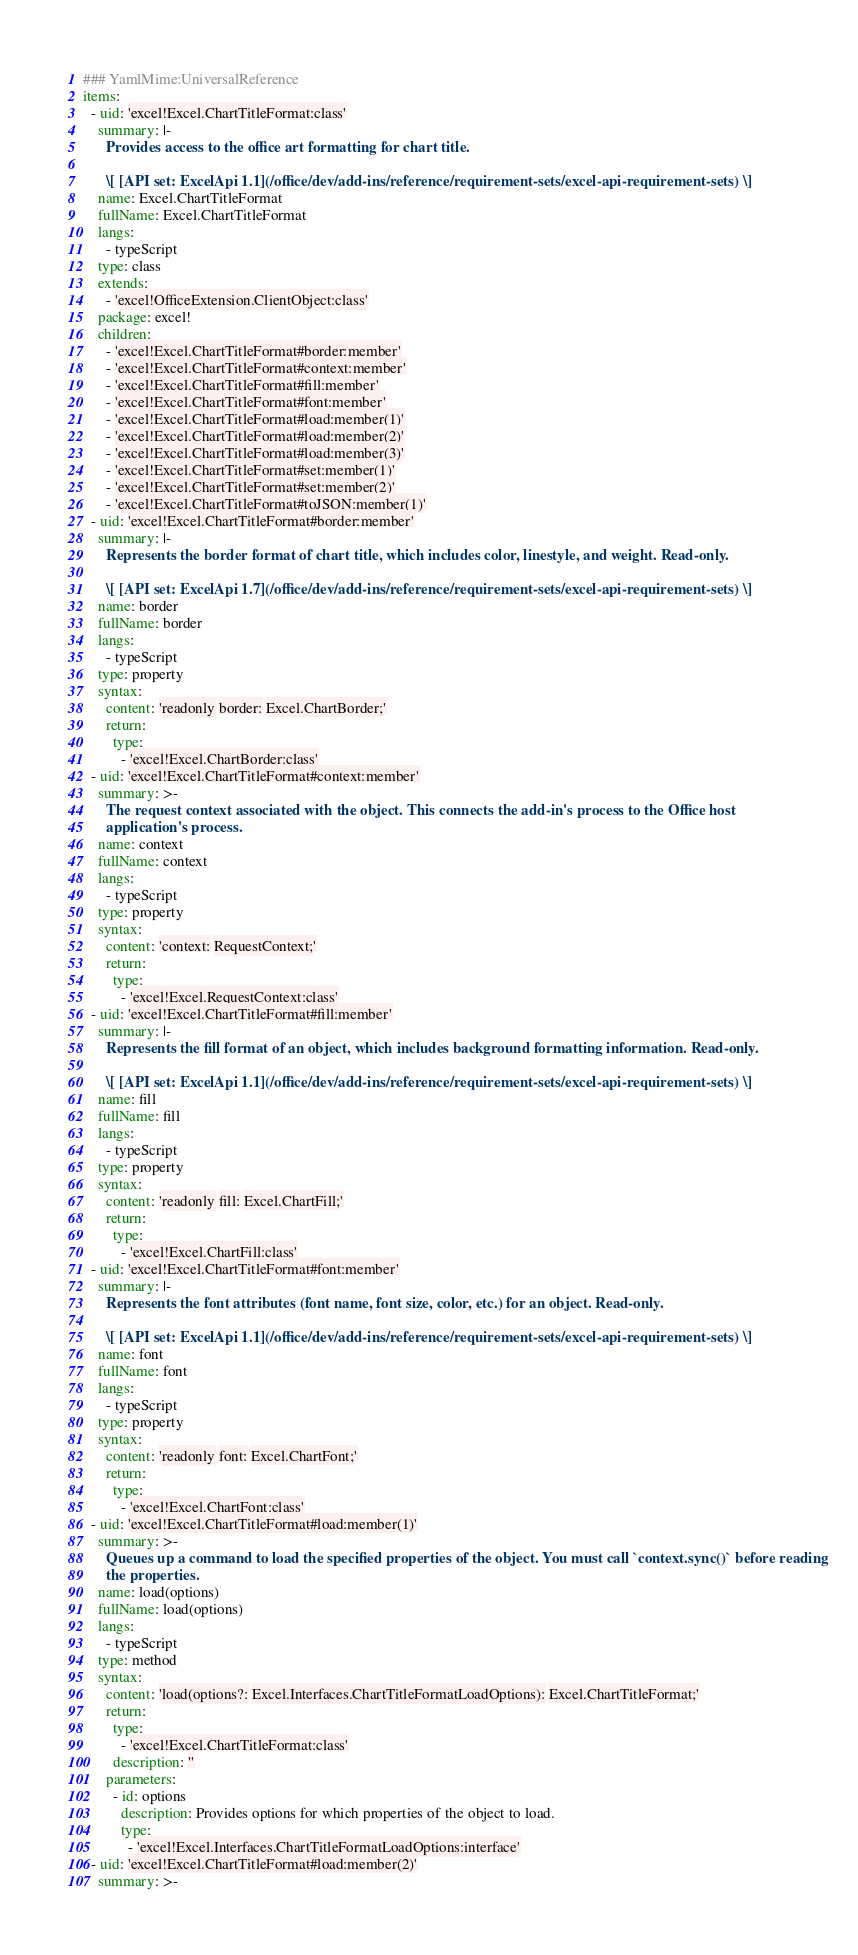<code> <loc_0><loc_0><loc_500><loc_500><_YAML_>### YamlMime:UniversalReference
items:
  - uid: 'excel!Excel.ChartTitleFormat:class'
    summary: |-
      Provides access to the office art formatting for chart title.

      \[ [API set: ExcelApi 1.1](/office/dev/add-ins/reference/requirement-sets/excel-api-requirement-sets) \]
    name: Excel.ChartTitleFormat
    fullName: Excel.ChartTitleFormat
    langs:
      - typeScript
    type: class
    extends:
      - 'excel!OfficeExtension.ClientObject:class'
    package: excel!
    children:
      - 'excel!Excel.ChartTitleFormat#border:member'
      - 'excel!Excel.ChartTitleFormat#context:member'
      - 'excel!Excel.ChartTitleFormat#fill:member'
      - 'excel!Excel.ChartTitleFormat#font:member'
      - 'excel!Excel.ChartTitleFormat#load:member(1)'
      - 'excel!Excel.ChartTitleFormat#load:member(2)'
      - 'excel!Excel.ChartTitleFormat#load:member(3)'
      - 'excel!Excel.ChartTitleFormat#set:member(1)'
      - 'excel!Excel.ChartTitleFormat#set:member(2)'
      - 'excel!Excel.ChartTitleFormat#toJSON:member(1)'
  - uid: 'excel!Excel.ChartTitleFormat#border:member'
    summary: |-
      Represents the border format of chart title, which includes color, linestyle, and weight. Read-only.

      \[ [API set: ExcelApi 1.7](/office/dev/add-ins/reference/requirement-sets/excel-api-requirement-sets) \]
    name: border
    fullName: border
    langs:
      - typeScript
    type: property
    syntax:
      content: 'readonly border: Excel.ChartBorder;'
      return:
        type:
          - 'excel!Excel.ChartBorder:class'
  - uid: 'excel!Excel.ChartTitleFormat#context:member'
    summary: >-
      The request context associated with the object. This connects the add-in's process to the Office host
      application's process.
    name: context
    fullName: context
    langs:
      - typeScript
    type: property
    syntax:
      content: 'context: RequestContext;'
      return:
        type:
          - 'excel!Excel.RequestContext:class'
  - uid: 'excel!Excel.ChartTitleFormat#fill:member'
    summary: |-
      Represents the fill format of an object, which includes background formatting information. Read-only.

      \[ [API set: ExcelApi 1.1](/office/dev/add-ins/reference/requirement-sets/excel-api-requirement-sets) \]
    name: fill
    fullName: fill
    langs:
      - typeScript
    type: property
    syntax:
      content: 'readonly fill: Excel.ChartFill;'
      return:
        type:
          - 'excel!Excel.ChartFill:class'
  - uid: 'excel!Excel.ChartTitleFormat#font:member'
    summary: |-
      Represents the font attributes (font name, font size, color, etc.) for an object. Read-only.

      \[ [API set: ExcelApi 1.1](/office/dev/add-ins/reference/requirement-sets/excel-api-requirement-sets) \]
    name: font
    fullName: font
    langs:
      - typeScript
    type: property
    syntax:
      content: 'readonly font: Excel.ChartFont;'
      return:
        type:
          - 'excel!Excel.ChartFont:class'
  - uid: 'excel!Excel.ChartTitleFormat#load:member(1)'
    summary: >-
      Queues up a command to load the specified properties of the object. You must call `context.sync()` before reading
      the properties.
    name: load(options)
    fullName: load(options)
    langs:
      - typeScript
    type: method
    syntax:
      content: 'load(options?: Excel.Interfaces.ChartTitleFormatLoadOptions): Excel.ChartTitleFormat;'
      return:
        type:
          - 'excel!Excel.ChartTitleFormat:class'
        description: ''
      parameters:
        - id: options
          description: Provides options for which properties of the object to load.
          type:
            - 'excel!Excel.Interfaces.ChartTitleFormatLoadOptions:interface'
  - uid: 'excel!Excel.ChartTitleFormat#load:member(2)'
    summary: >-</code> 